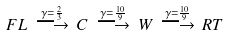Convert formula to latex. <formula><loc_0><loc_0><loc_500><loc_500>F L \, \overset { \gamma = \frac { 2 } { 3 } } { \longrightarrow } \, C \, \overset { \gamma = \frac { 1 0 } { 9 } } { \longrightarrow } \, W \, \overset { \gamma = \frac { 1 0 } { 9 } } { \longrightarrow } \, R T</formula> 